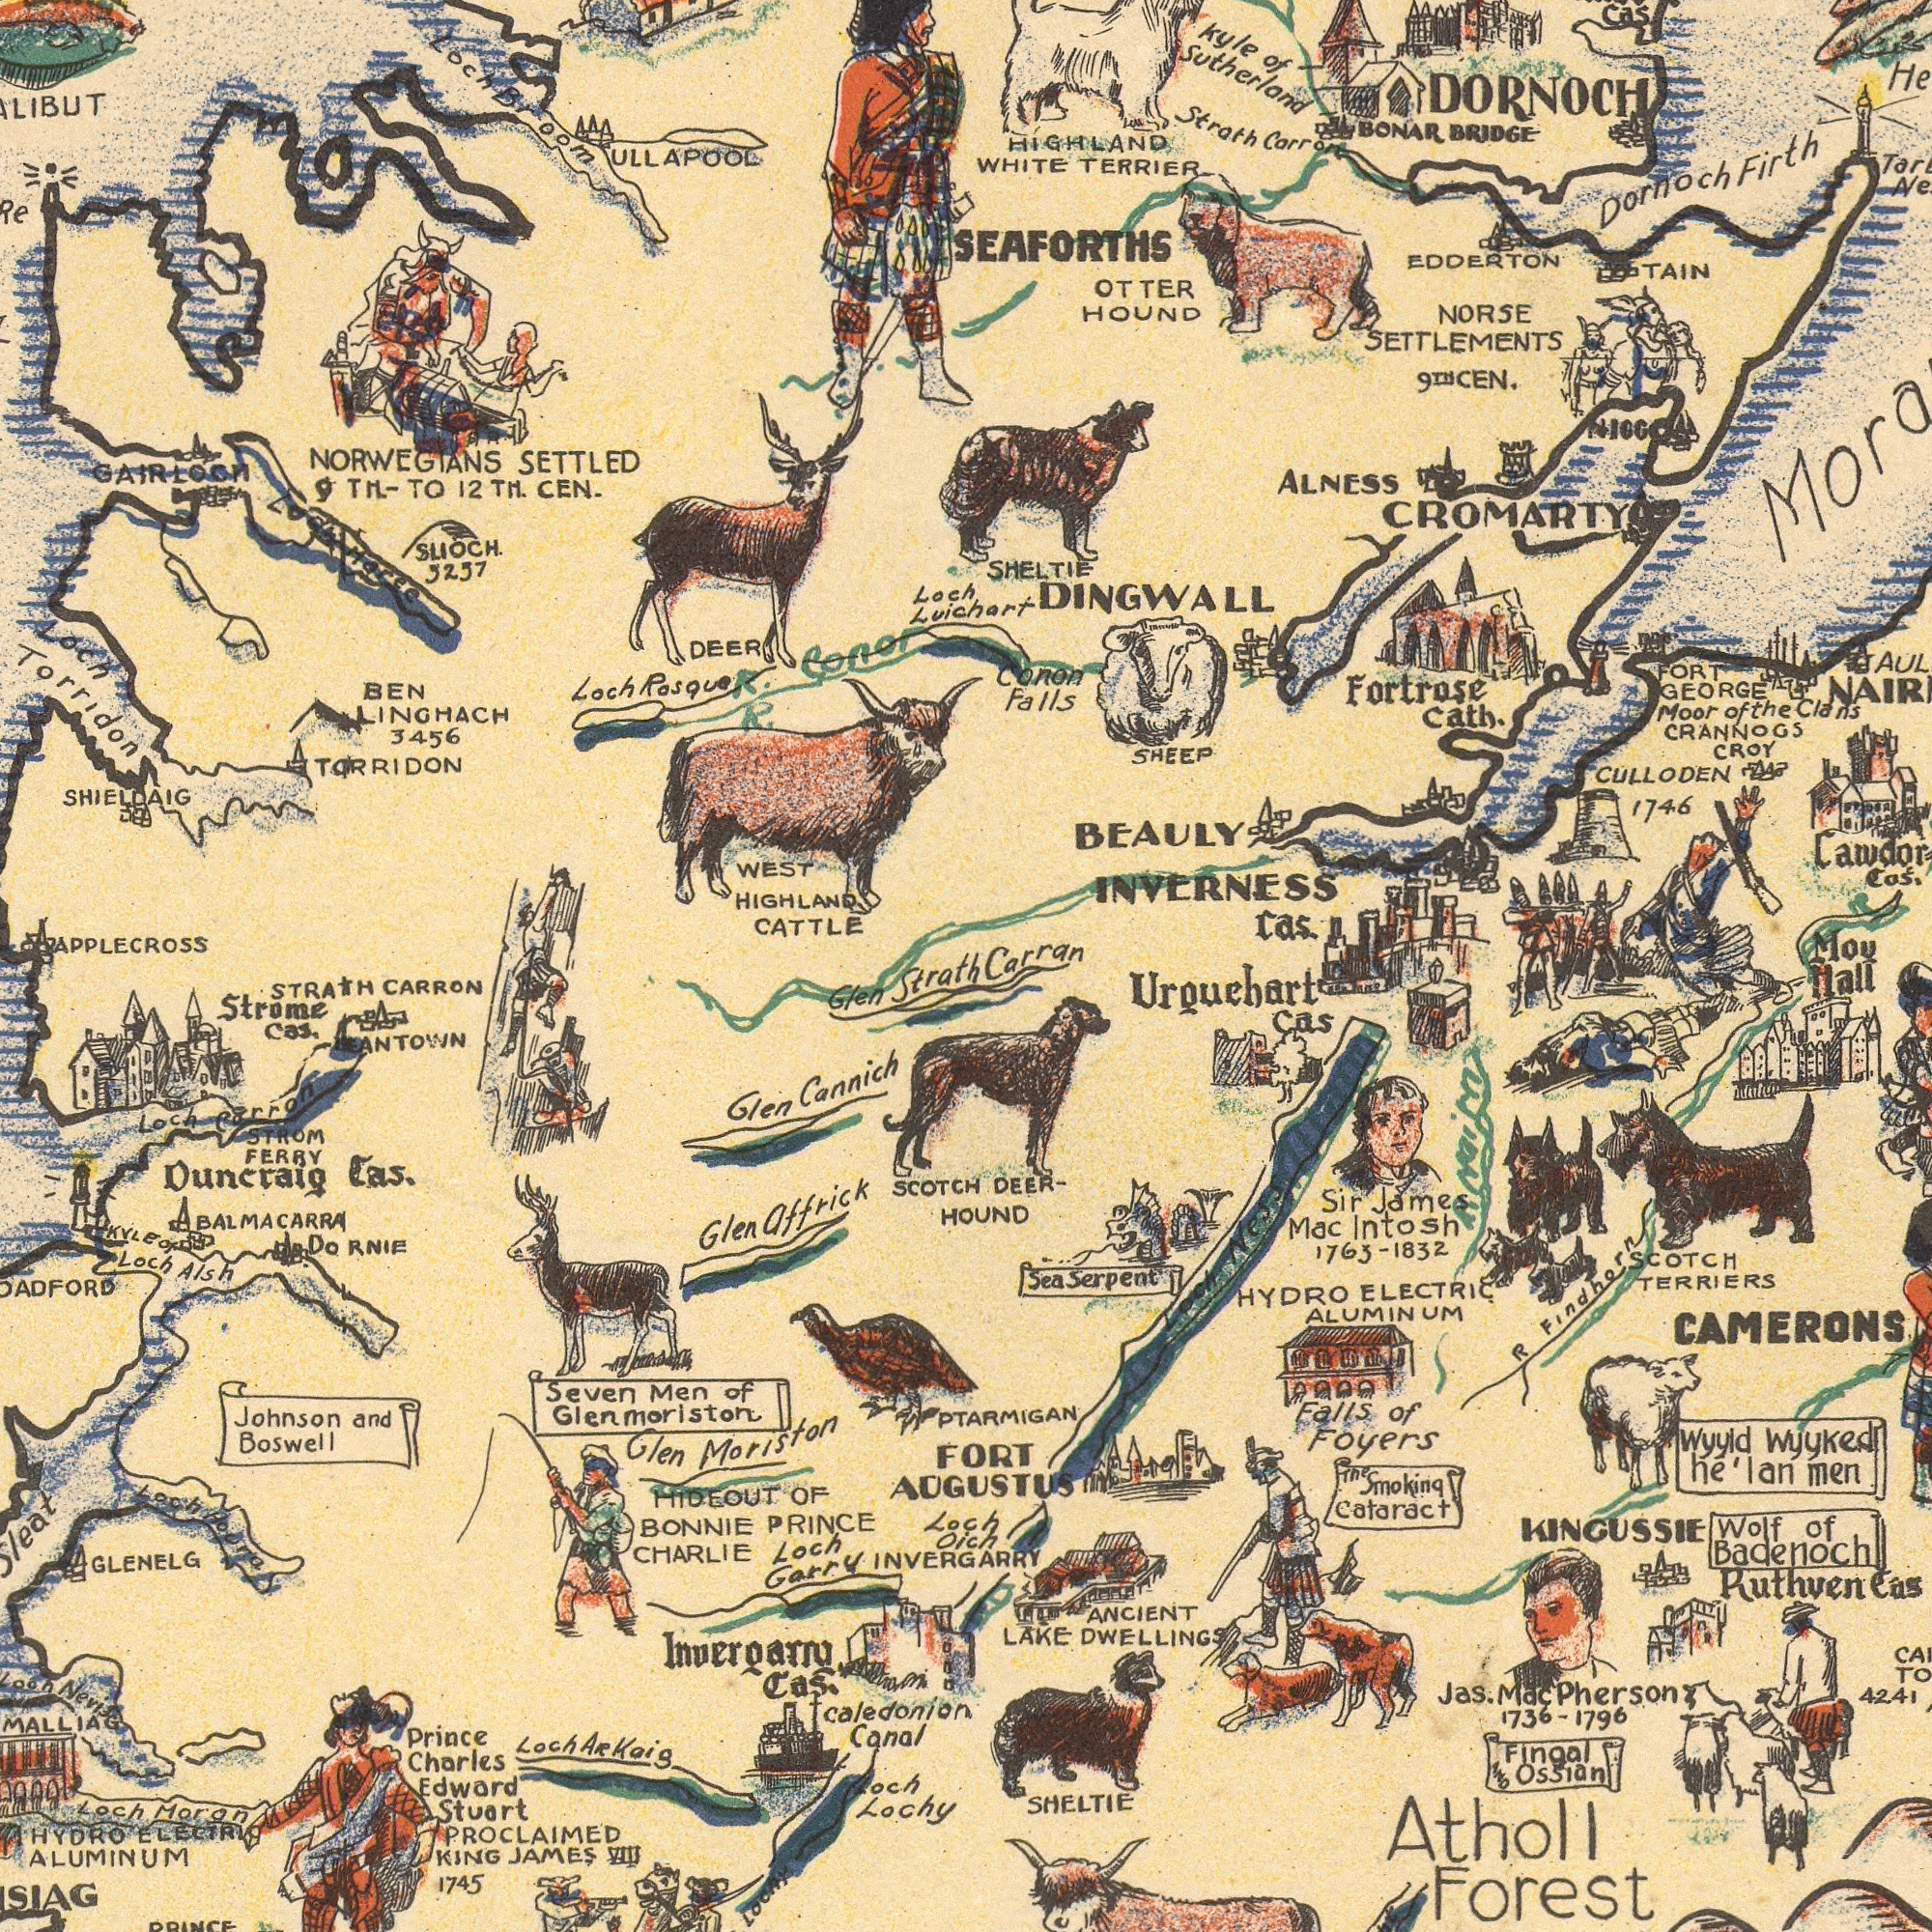What text can you see in the bottom-left section? Glen Strath BALMACARRA ANTOWN SCOTCH Glen Cannich Loch Lochy Johnson and Boswell Caledonian Canal PROCLAIMED KING JAMES 1745 Glen affrick Prince Charles Edward Stuart GLENELG Invergarry Cas. Seven Men of Glenmoriston ALUMINUM Duncraig Cas. HYDRO ELECTRIC Glen Moriston STRATH CARRON Strome Cas. Loch Corron KYLE Of Loch Alsh Loch Nevis Loch Moran STROM FERRY MALLIAG Loch Arkaig PRINCE Do RNIE Loch Houra HIDEOUT OF BONNIE PRINCE CHARLIE Loch Garry Loch Oich INVERGARRY What text appears in the top-right area of the image? Luichart Kyle of Sutherland BEAULY INVERNESS DORNOCH SHELTIE Dornoch Firth HIGHLAND WHITE TERRIER CULLODEN 1746 NORSE SETTLEMENTS 9TH CEN. Cas. Strath Carron DINGWALL OTTER HOUND Cawdor Cas. SHEEP CROMARTY Conon Falls Mou Moor of the Clans Fortrose cath. CRANNOGS CROY SEAFORTHS FORT GEORGE ALNESS EDDERTON TAIN Cas. BONAR BRIDGE NIOG Carran What text is shown in the bottom-right quadrant? Hall DEER- HOUND Urgucbart Cas Wolf of Badenoch SHELTIE Falls of Foyers KINGUSSIE FORT AUGUSTUS The Smoking Cataract SCOTCH TERRIERS ANCIENT LAKE DWELLINGS Fingal Ossian Sir James Mac Intosh 1763-1832 PTARMIGAN Ruthven Cas Sea Serpent CAMERONS HYDRO ELECTRIC ALUMINUM R Findhorn Atholl Forest wyyld wyyked he' lan men Jas. Mac Pherson 1736-1796 Loch Ness 42.41 What text can you see in the top-left section? GAIRLOOM WEST HIGHLAND CATTLE TARRIDON ULLAPOOL SLIOCH. 5257 SHIELDAIG Loch Torridon NORWEGIANS SETTLED 9TH. -TO 12TH. CEN. APPLECROSS BEN LINGHACH 3456 R. Loch Rosque DEER R. Conor Loch Loch Moree Loch Broom 